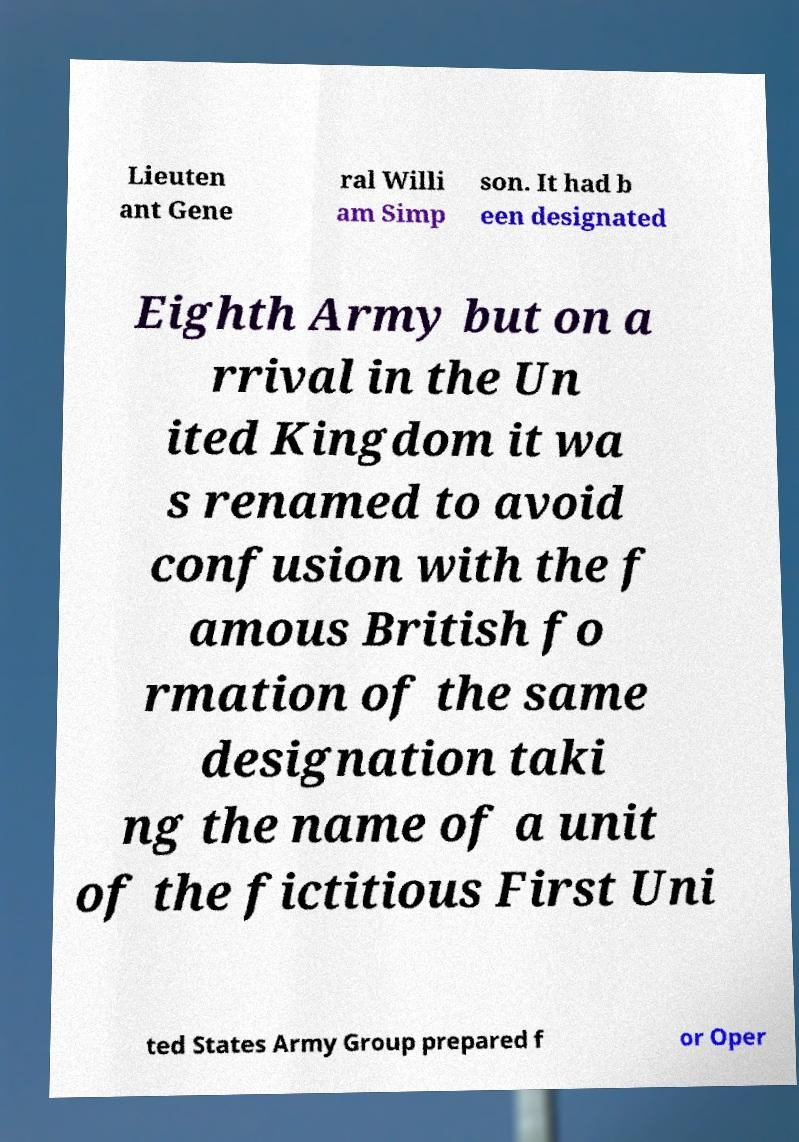Can you read and provide the text displayed in the image?This photo seems to have some interesting text. Can you extract and type it out for me? Lieuten ant Gene ral Willi am Simp son. It had b een designated Eighth Army but on a rrival in the Un ited Kingdom it wa s renamed to avoid confusion with the f amous British fo rmation of the same designation taki ng the name of a unit of the fictitious First Uni ted States Army Group prepared f or Oper 